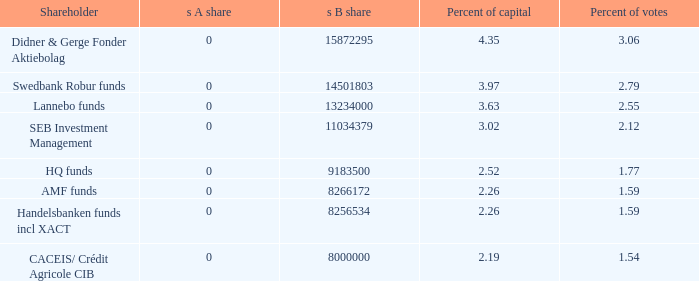Give me the full table as a dictionary. {'header': ['Shareholder', 's A share', 's B share', 'Percent of capital', 'Percent of votes'], 'rows': [['Didner & Gerge Fonder Aktiebolag', '0', '15872295', '4.35', '3.06'], ['Swedbank Robur funds', '0', '14501803', '3.97', '2.79'], ['Lannebo funds', '0', '13234000', '3.63', '2.55'], ['SEB Investment Management', '0', '11034379', '3.02', '2.12'], ['HQ funds', '0', '9183500', '2.52', '1.77'], ['AMF funds', '0', '8266172', '2.26', '1.59'], ['Handelsbanken funds incl XACT', '0', '8256534', '2.26', '1.59'], ['CACEIS/ Crédit Agricole CIB', '0', '8000000', '2.19', '1.54']]} What shareholder has 2.55 percent of votes?  Lannebo funds. 